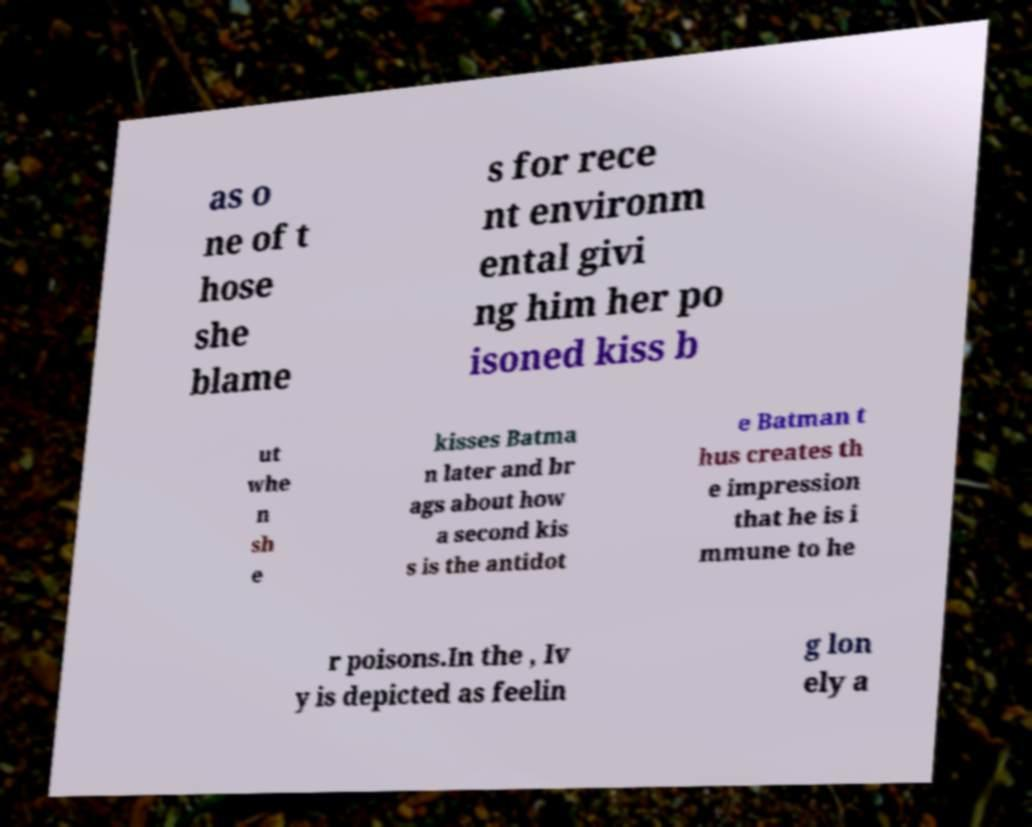Can you read and provide the text displayed in the image?This photo seems to have some interesting text. Can you extract and type it out for me? as o ne of t hose she blame s for rece nt environm ental givi ng him her po isoned kiss b ut whe n sh e kisses Batma n later and br ags about how a second kis s is the antidot e Batman t hus creates th e impression that he is i mmune to he r poisons.In the , Iv y is depicted as feelin g lon ely a 